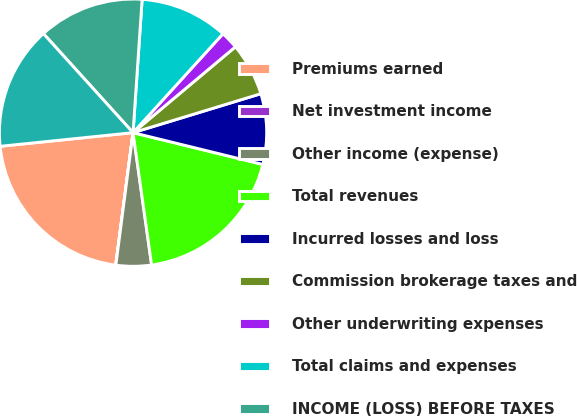Convert chart to OTSL. <chart><loc_0><loc_0><loc_500><loc_500><pie_chart><fcel>Premiums earned<fcel>Net investment income<fcel>Other income (expense)<fcel>Total revenues<fcel>Incurred losses and loss<fcel>Commission brokerage taxes and<fcel>Other underwriting expenses<fcel>Total claims and expenses<fcel>INCOME (LOSS) BEFORE TAXES<fcel>NET INCOME (LOSS)<nl><fcel>21.3%<fcel>0.02%<fcel>4.27%<fcel>18.96%<fcel>8.53%<fcel>6.4%<fcel>2.15%<fcel>10.66%<fcel>12.79%<fcel>14.92%<nl></chart> 